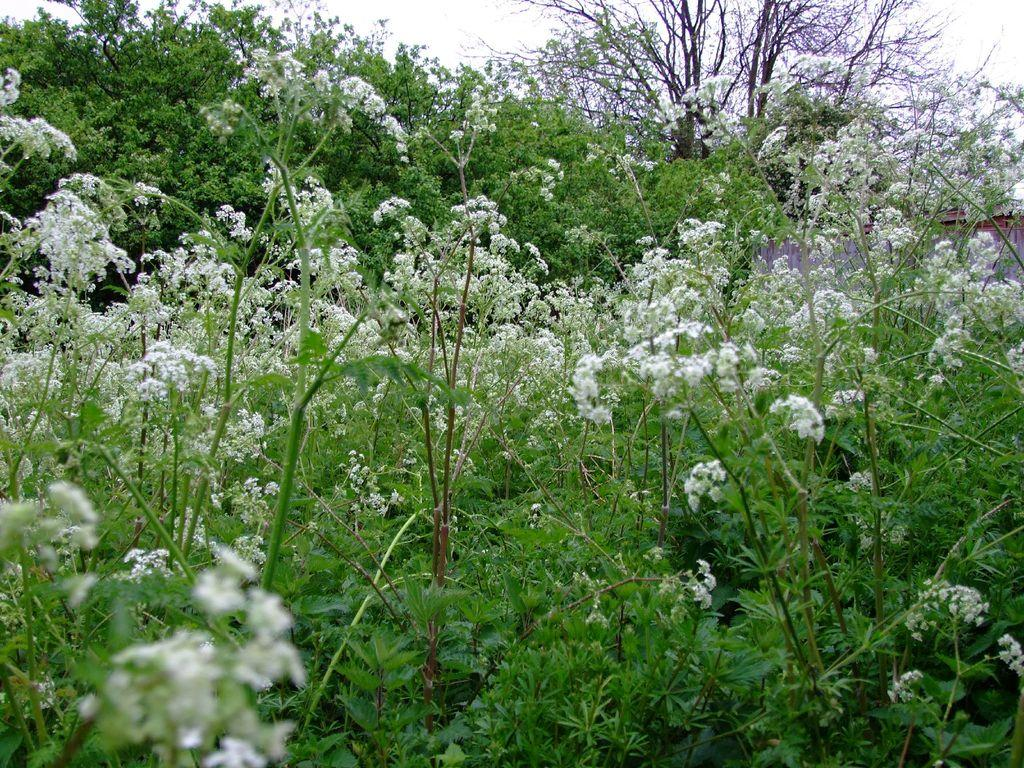What type of vegetation can be seen in the image? There are trees in the image. What other natural elements are present in the image? There are flowers in the image. What can be seen in the background of the image? The sky is visible in the background of the image. What type of current is flowing through the flowers in the image? There is no current present in the image; it is a still image of trees and flowers. Can you see any blood on the leaves of the trees in the image? There is no blood present in the image; it features trees and flowers in a natural setting. 